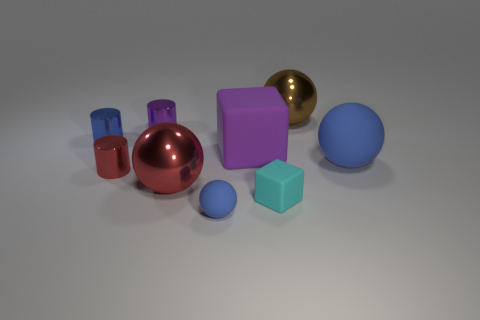There is a red shiny thing that is on the left side of the purple thing behind the big cube; are there any purple shiny cylinders that are right of it?
Keep it short and to the point. Yes. How many metallic objects are blue cylinders or purple cubes?
Offer a terse response. 1. What number of other objects are there of the same shape as the brown metal thing?
Your answer should be compact. 3. Are there more red shiny spheres than big things?
Offer a terse response. No. There is a rubber object behind the matte ball to the right of the large metallic sphere behind the large blue rubber thing; what is its size?
Offer a terse response. Large. There is a matte sphere on the right side of the big rubber cube; what is its size?
Ensure brevity in your answer.  Large. How many things are either tiny purple shiny cylinders or blue things to the left of the big brown sphere?
Give a very brief answer. 3. How many other objects are there of the same size as the purple rubber cube?
Ensure brevity in your answer.  3. What material is the red thing that is the same shape as the brown thing?
Provide a succinct answer. Metal. Is the number of matte balls that are to the left of the tiny cyan thing greater than the number of cyan shiny cylinders?
Make the answer very short. Yes. 